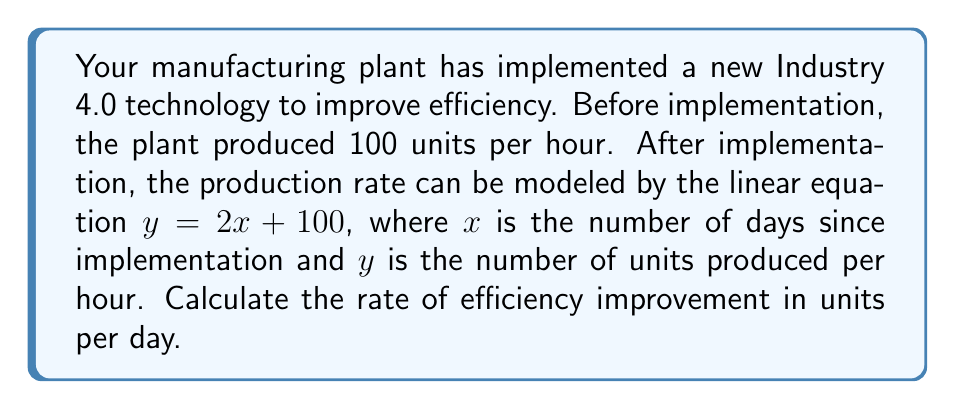Help me with this question. To solve this problem, we'll follow these steps:

1) The linear equation given is $y = 2x + 100$, where:
   $y$ = units produced per hour
   $x$ = number of days since implementation
   100 = initial production rate (y-intercept)

2) The slope of this line represents the rate of change in production per day. In a linear equation of the form $y = mx + b$, $m$ represents the slope.

3) In our equation $y = 2x + 100$, the coefficient of $x$ is 2. This means:

   $$\text{Rate of change} = 2 \text{ units per hour per day}$$

4) However, we need to express this as units per day, not units per hour per day. To do this, we need to multiply by the number of hours in a day:

   $$\text{Rate of change} = 2 \text{ units/hour/day} \times 24 \text{ hours/day}$$
   $$= 48 \text{ units/day}$$

5) Therefore, the efficiency is improving at a rate of 48 units per day.
Answer: 48 units/day 